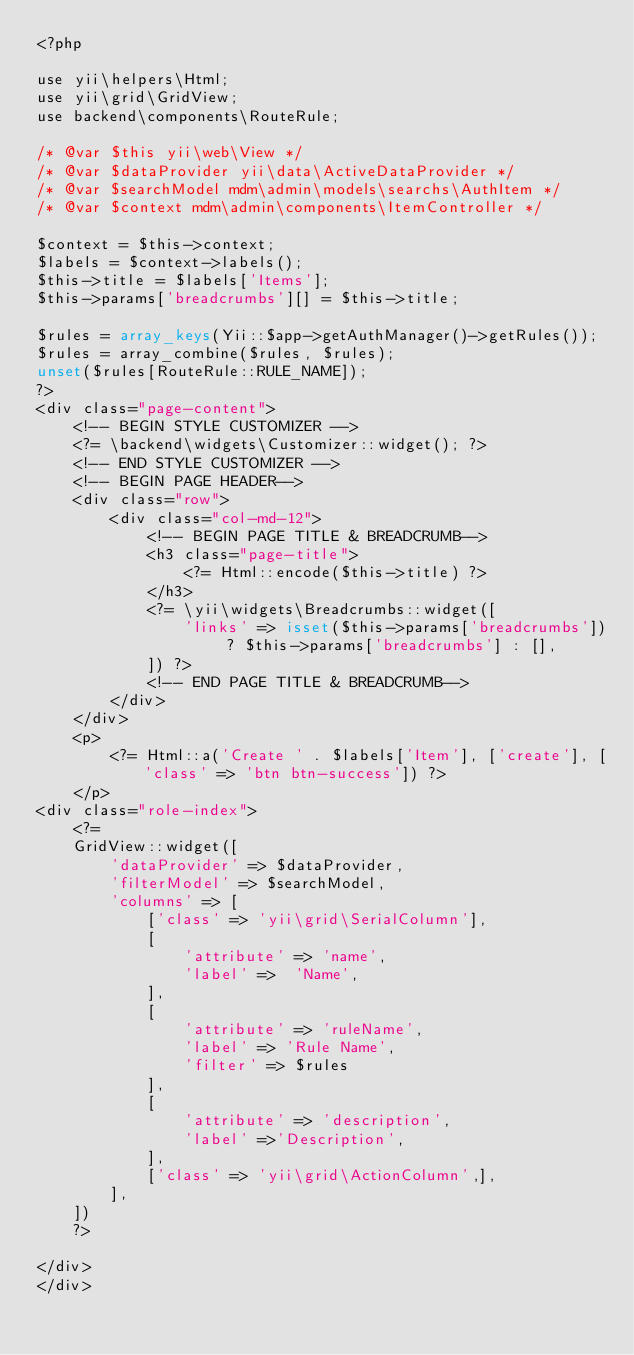Convert code to text. <code><loc_0><loc_0><loc_500><loc_500><_PHP_><?php

use yii\helpers\Html;
use yii\grid\GridView;
use backend\components\RouteRule;

/* @var $this yii\web\View */
/* @var $dataProvider yii\data\ActiveDataProvider */
/* @var $searchModel mdm\admin\models\searchs\AuthItem */
/* @var $context mdm\admin\components\ItemController */

$context = $this->context;
$labels = $context->labels();
$this->title = $labels['Items'];
$this->params['breadcrumbs'][] = $this->title;

$rules = array_keys(Yii::$app->getAuthManager()->getRules());
$rules = array_combine($rules, $rules);
unset($rules[RouteRule::RULE_NAME]);
?>
<div class="page-content">
    <!-- BEGIN STYLE CUSTOMIZER -->
    <?= \backend\widgets\Customizer::widget(); ?>
    <!-- END STYLE CUSTOMIZER -->
    <!-- BEGIN PAGE HEADER-->
    <div class="row">
        <div class="col-md-12">
            <!-- BEGIN PAGE TITLE & BREADCRUMB-->
            <h3 class="page-title">
                <?= Html::encode($this->title) ?>
            </h3>
            <?= \yii\widgets\Breadcrumbs::widget([
                'links' => isset($this->params['breadcrumbs']) ? $this->params['breadcrumbs'] : [],
            ]) ?>
            <!-- END PAGE TITLE & BREADCRUMB-->
        </div>
    </div>
    <p>
        <?= Html::a('Create ' . $labels['Item'], ['create'], ['class' => 'btn btn-success']) ?>
    </p>
<div class="role-index">
    <?=
    GridView::widget([
        'dataProvider' => $dataProvider,
        'filterModel' => $searchModel,
        'columns' => [
            ['class' => 'yii\grid\SerialColumn'],
            [
                'attribute' => 'name',
                'label' =>  'Name',
            ],
            [
                'attribute' => 'ruleName',
                'label' => 'Rule Name',
                'filter' => $rules
            ],
            [
                'attribute' => 'description',
                'label' =>'Description',
            ],
            ['class' => 'yii\grid\ActionColumn',],
        ],
    ])
    ?>

</div>
</div></code> 